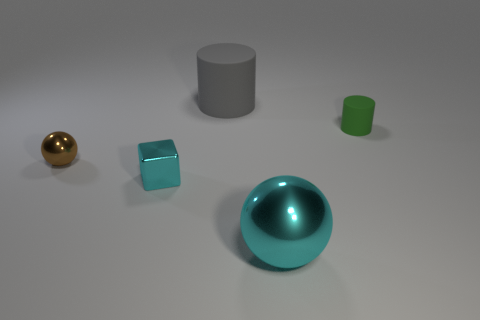Are there any other things that are the same color as the metallic block?
Your answer should be very brief. Yes. There is a thing that is made of the same material as the small green cylinder; what size is it?
Provide a short and direct response. Large. What number of large objects are yellow shiny blocks or gray cylinders?
Provide a succinct answer. 1. There is a cyan object that is in front of the cyan metal thing behind the cyan thing that is right of the large cylinder; how big is it?
Give a very brief answer. Large. What number of other cubes are the same size as the block?
Your response must be concise. 0. What number of objects are tiny matte cylinders or rubber cylinders in front of the large cylinder?
Offer a very short reply. 1. What is the shape of the large gray object?
Offer a terse response. Cylinder. Does the metal cube have the same color as the big shiny sphere?
Your answer should be compact. Yes. There is a sphere that is the same size as the gray object; what is its color?
Provide a succinct answer. Cyan. How many brown things are metal spheres or shiny blocks?
Offer a very short reply. 1. 